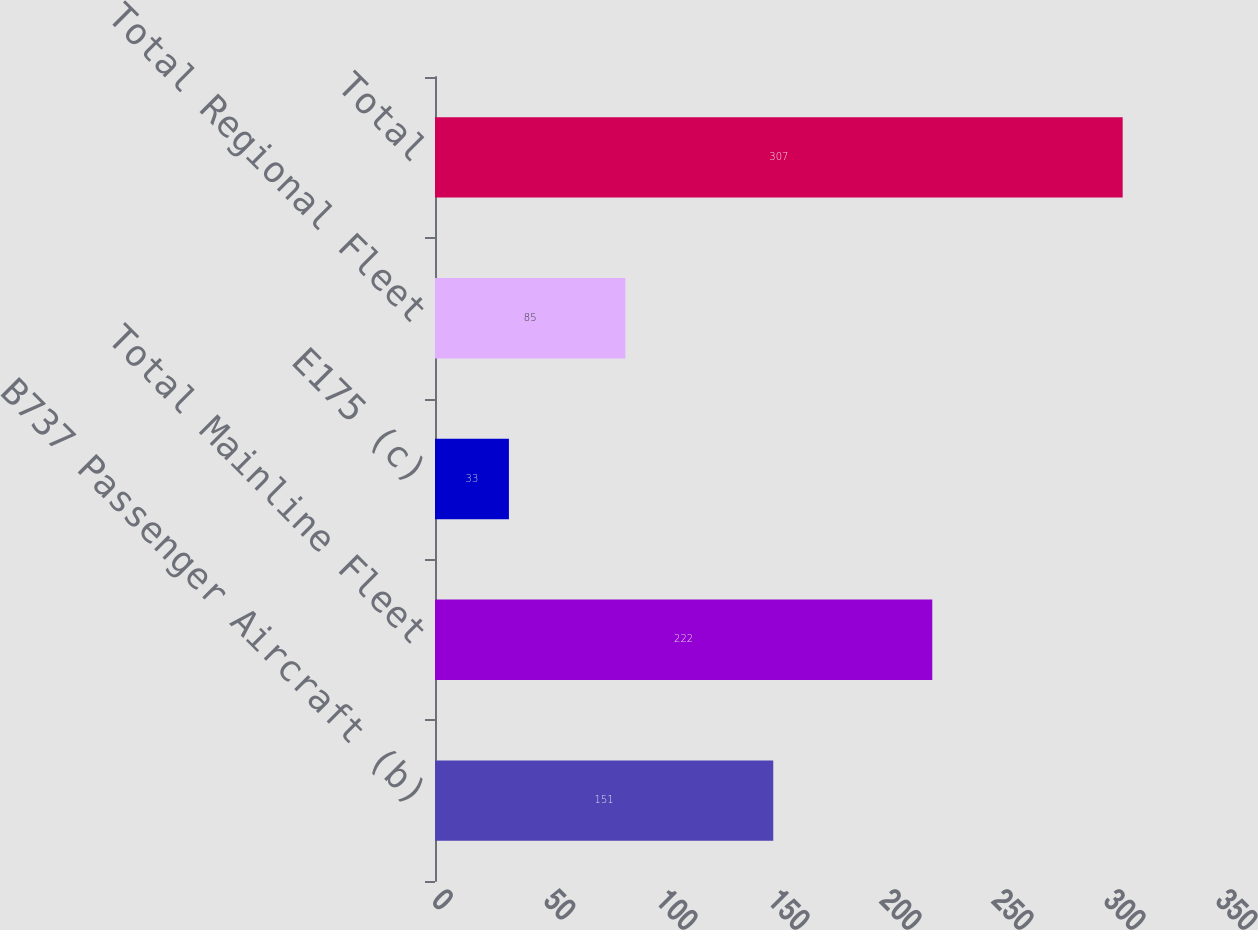Convert chart to OTSL. <chart><loc_0><loc_0><loc_500><loc_500><bar_chart><fcel>B737 Passenger Aircraft (b)<fcel>Total Mainline Fleet<fcel>E175 (c)<fcel>Total Regional Fleet<fcel>Total<nl><fcel>151<fcel>222<fcel>33<fcel>85<fcel>307<nl></chart> 